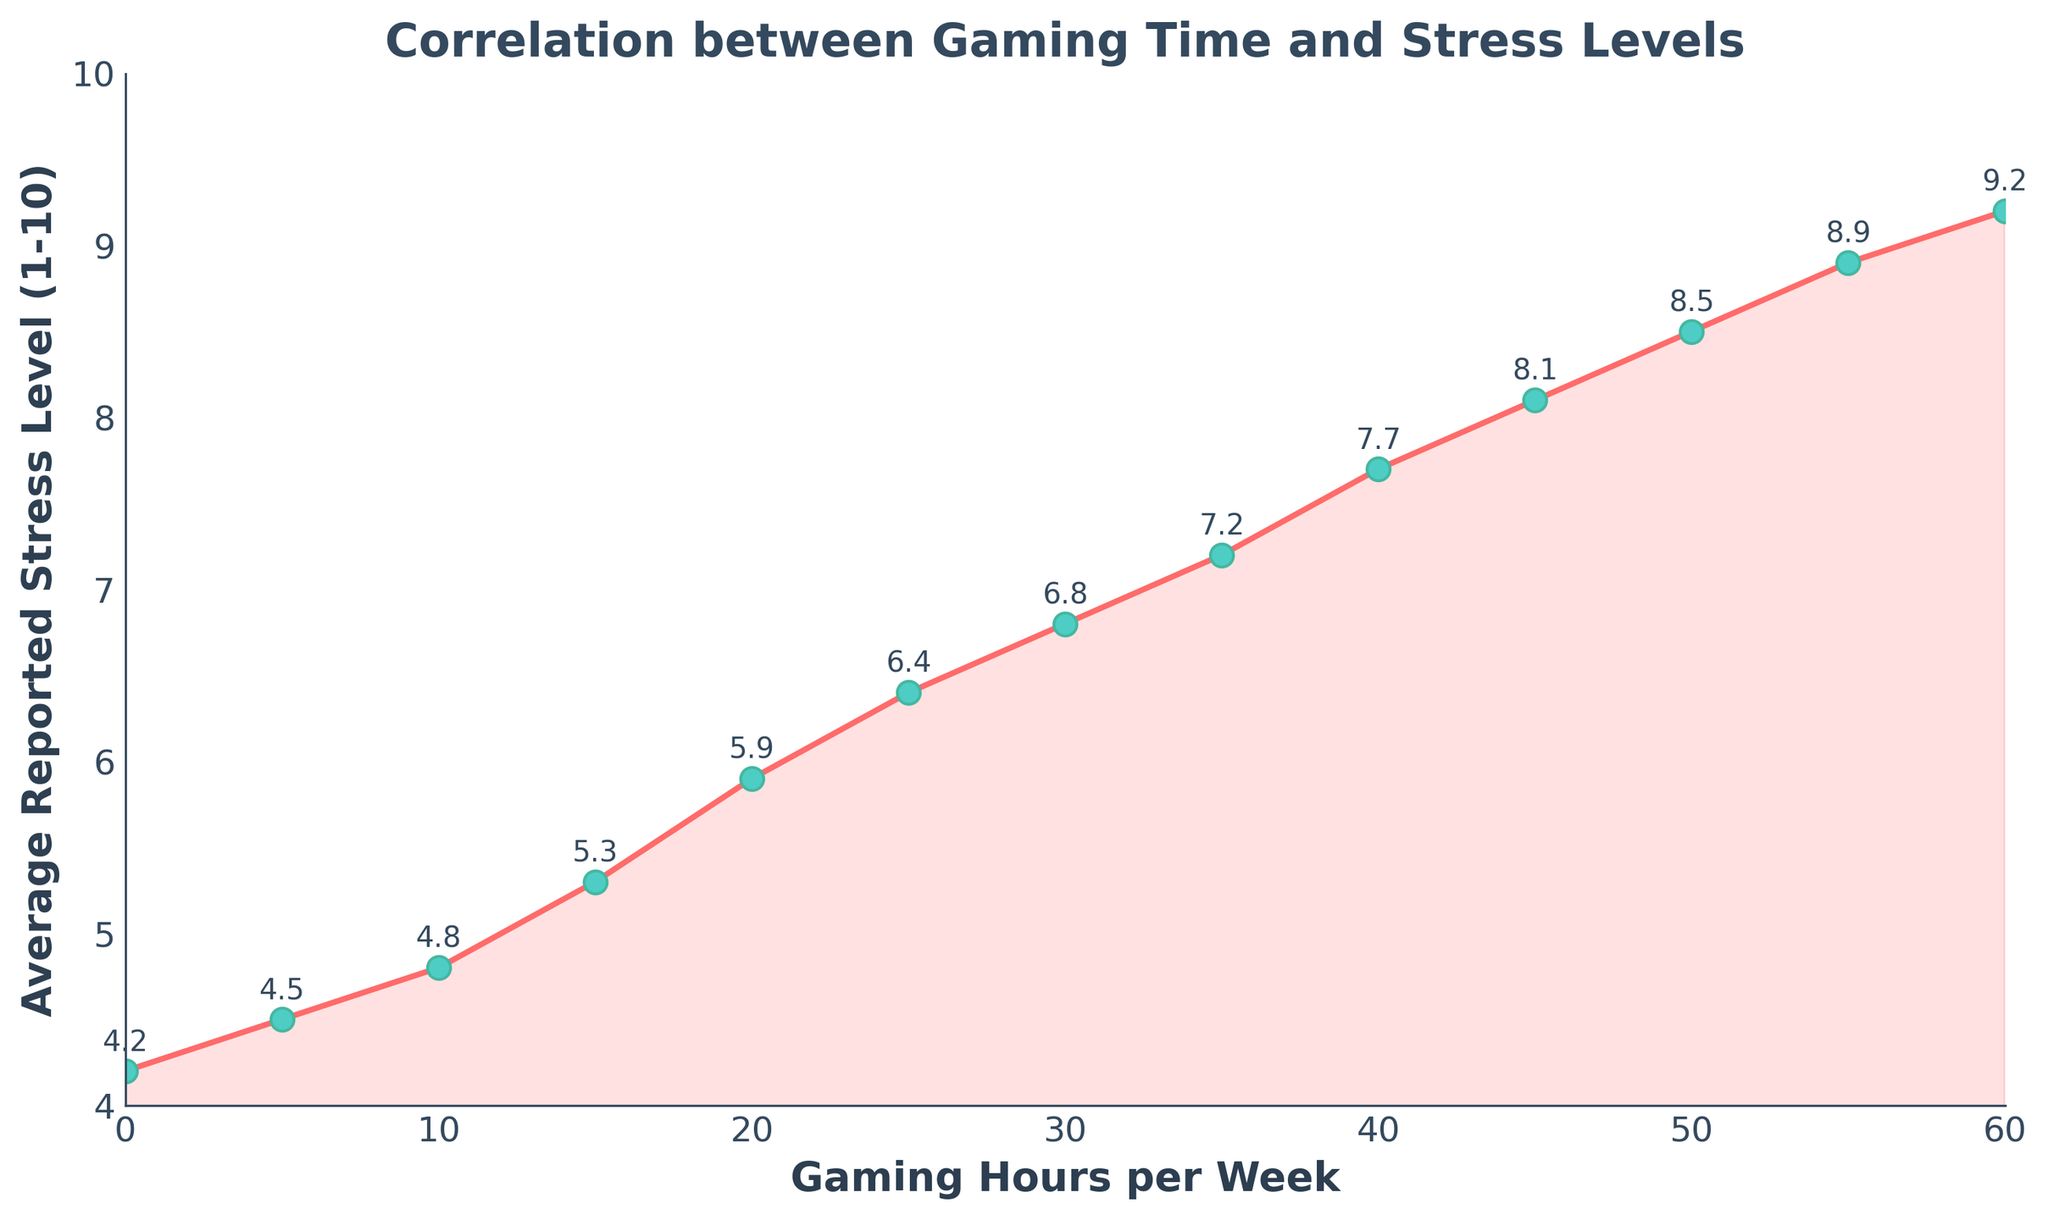What's the reported stress level at 30 gaming hours per week? Look at the point on the graph where the x-axis (Gaming Hours per Week) is 30. The corresponding point on the y-axis (Average Reported Stress Level) is 6.8.
Answer: 6.8 At what gaming hours per week does the average reported stress level first exceed 8? Identify the point on the graph where the y-value (Average Reported Stress Level) first goes above 8. At 45 gaming hours per week, the stress level is 8.1.
Answer: 45 hours per week How does the stress level change as gaming hours increase from 20 to 40 hours per week? Check the y-values at 20 and 40 gaming hours per week. The stress level rises from 5.9 to 7.7, indicating an increase of 1.8 units.
Answer: Increases by 1.8 units Which gaming hours per week shows the highest reported stress level? Look for the highest y-value on the graph. The highest reported stress level is 9.2 at 60 gaming hours per week.
Answer: 60 hours per week Compare the stress levels at 10 and 50 gaming hours per week. Which is higher and by how much? Look at the y-values for 10 and 50 gaming hours per week. The stress levels are 4.8 and 8.5, respectively. Subtract 4.8 from 8.5 to find the difference, which is 3.7.
Answer: 50 hours per week is higher by 3.7 units What is the average of the stress levels at 5, 25, and 55 gaming hours per week? Find the stress levels for 5, 25, and 55 gaming hours per week, which are 4.5, 6.4, and 8.9, respectively. Calculate the average: (4.5 + 6.4 + 8.9) / 3 = 6.6.
Answer: 6.6 Is there a consistent increase in stress level with increasing gaming hours per week? Observe the trend in the graph. The line consistently slopes upwards as gaming hours increase, indicating a continuous rise in stress levels.
Answer: Yes Between which two gaming hour ranges does the biggest jump in stress level occur? Examine the differences between consecutive points. The largest jump is from 50 to 55 gaming hours per week (8.5 to 8.9), which is an increase of 0.4 units.
Answer: 50 to 55 hours per week What is the total increase in stress level from 0 to 60 gaming hours per week? Find the stress levels at 0 and 60 hours per week, which are 4.2 and 9.2, respectively. Subtract 4.2 from 9.2 to find the total increase, which is 5 units.
Answer: 5 units 